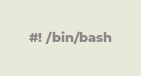<code> <loc_0><loc_0><loc_500><loc_500><_Bash_>#! /bin/bash
</code> 